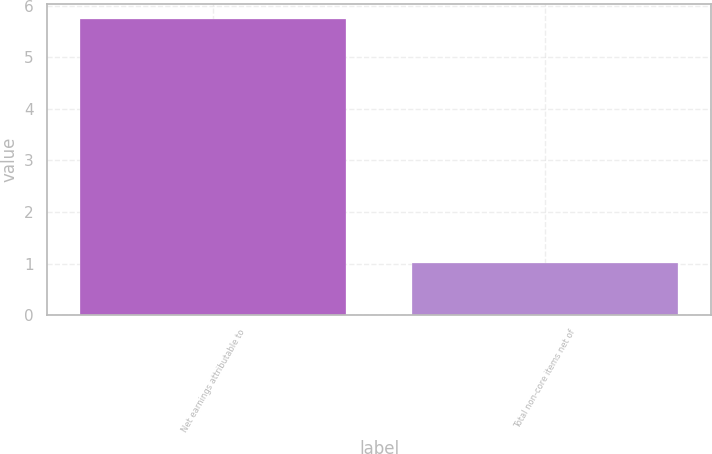Convert chart to OTSL. <chart><loc_0><loc_0><loc_500><loc_500><bar_chart><fcel>Net earnings attributable to<fcel>Total non-core items net of<nl><fcel>5.75<fcel>1.01<nl></chart> 